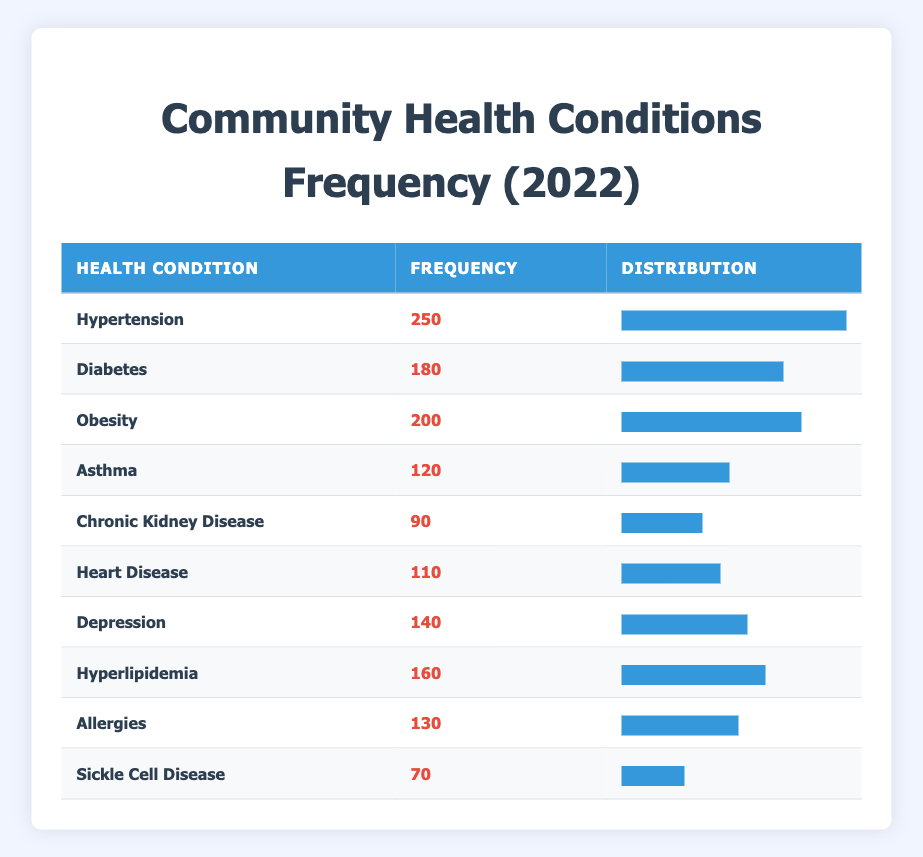What is the frequency of Hypertension reported in 2022? The table shows that Hypertension has a frequency of 250. Therefore, the answer is directly taken from the table.
Answer: 250 Which health condition has the lowest frequency? By inspecting each frequency value in the table, Sickle Cell Disease has a frequency of 70, which is the smallest among all listed conditions.
Answer: Sickle Cell Disease How many total cases of Diabetes and Depression were reported? To find the total, add the frequencies of Diabetes (180) and Depression (140): 180 + 140 = 320.
Answer: 320 Is the frequency of Asthma greater than the frequency of Heart Disease? According to the table, Asthma has a frequency of 120 and Heart Disease has a frequency of 110. Since 120 is greater than 110, the statement is true.
Answer: Yes What is the average frequency of all health conditions listed? To calculate the average, sum all the frequencies: 250 + 180 + 200 + 120 + 90 + 110 + 140 + 160 + 130 + 70 = 1,520. There are 10 conditions, so the average is 1,520 / 10 = 152.
Answer: 152 Which condition has a frequency closest to the average frequency? The average frequency is 152. Looking at the frequencies, Obesity is 200, which is 48 above average; Depression is 140, just 12 below average, making it closer to the average frequency than any other condition.
Answer: Depression How much more frequent is Hypertension compared to Chronic Kidney Disease? Hypertension has a frequency of 250, and Chronic Kidney Disease has a frequency of 90. To find the difference, subtract: 250 - 90 = 160.
Answer: 160 Are there more than 150 reported cases of Hyperlipidemia? Hyperlipidemia shows a frequency of 160. Since 160 is greater than 150, the statement is true.
Answer: Yes What percentage of the total cases does Obesity represent? First, find the total frequency: 1,520. Obesity has a frequency of 200. To calculate the percentage: (200 / 1,520) * 100 = 13.16%.
Answer: 13.16% 